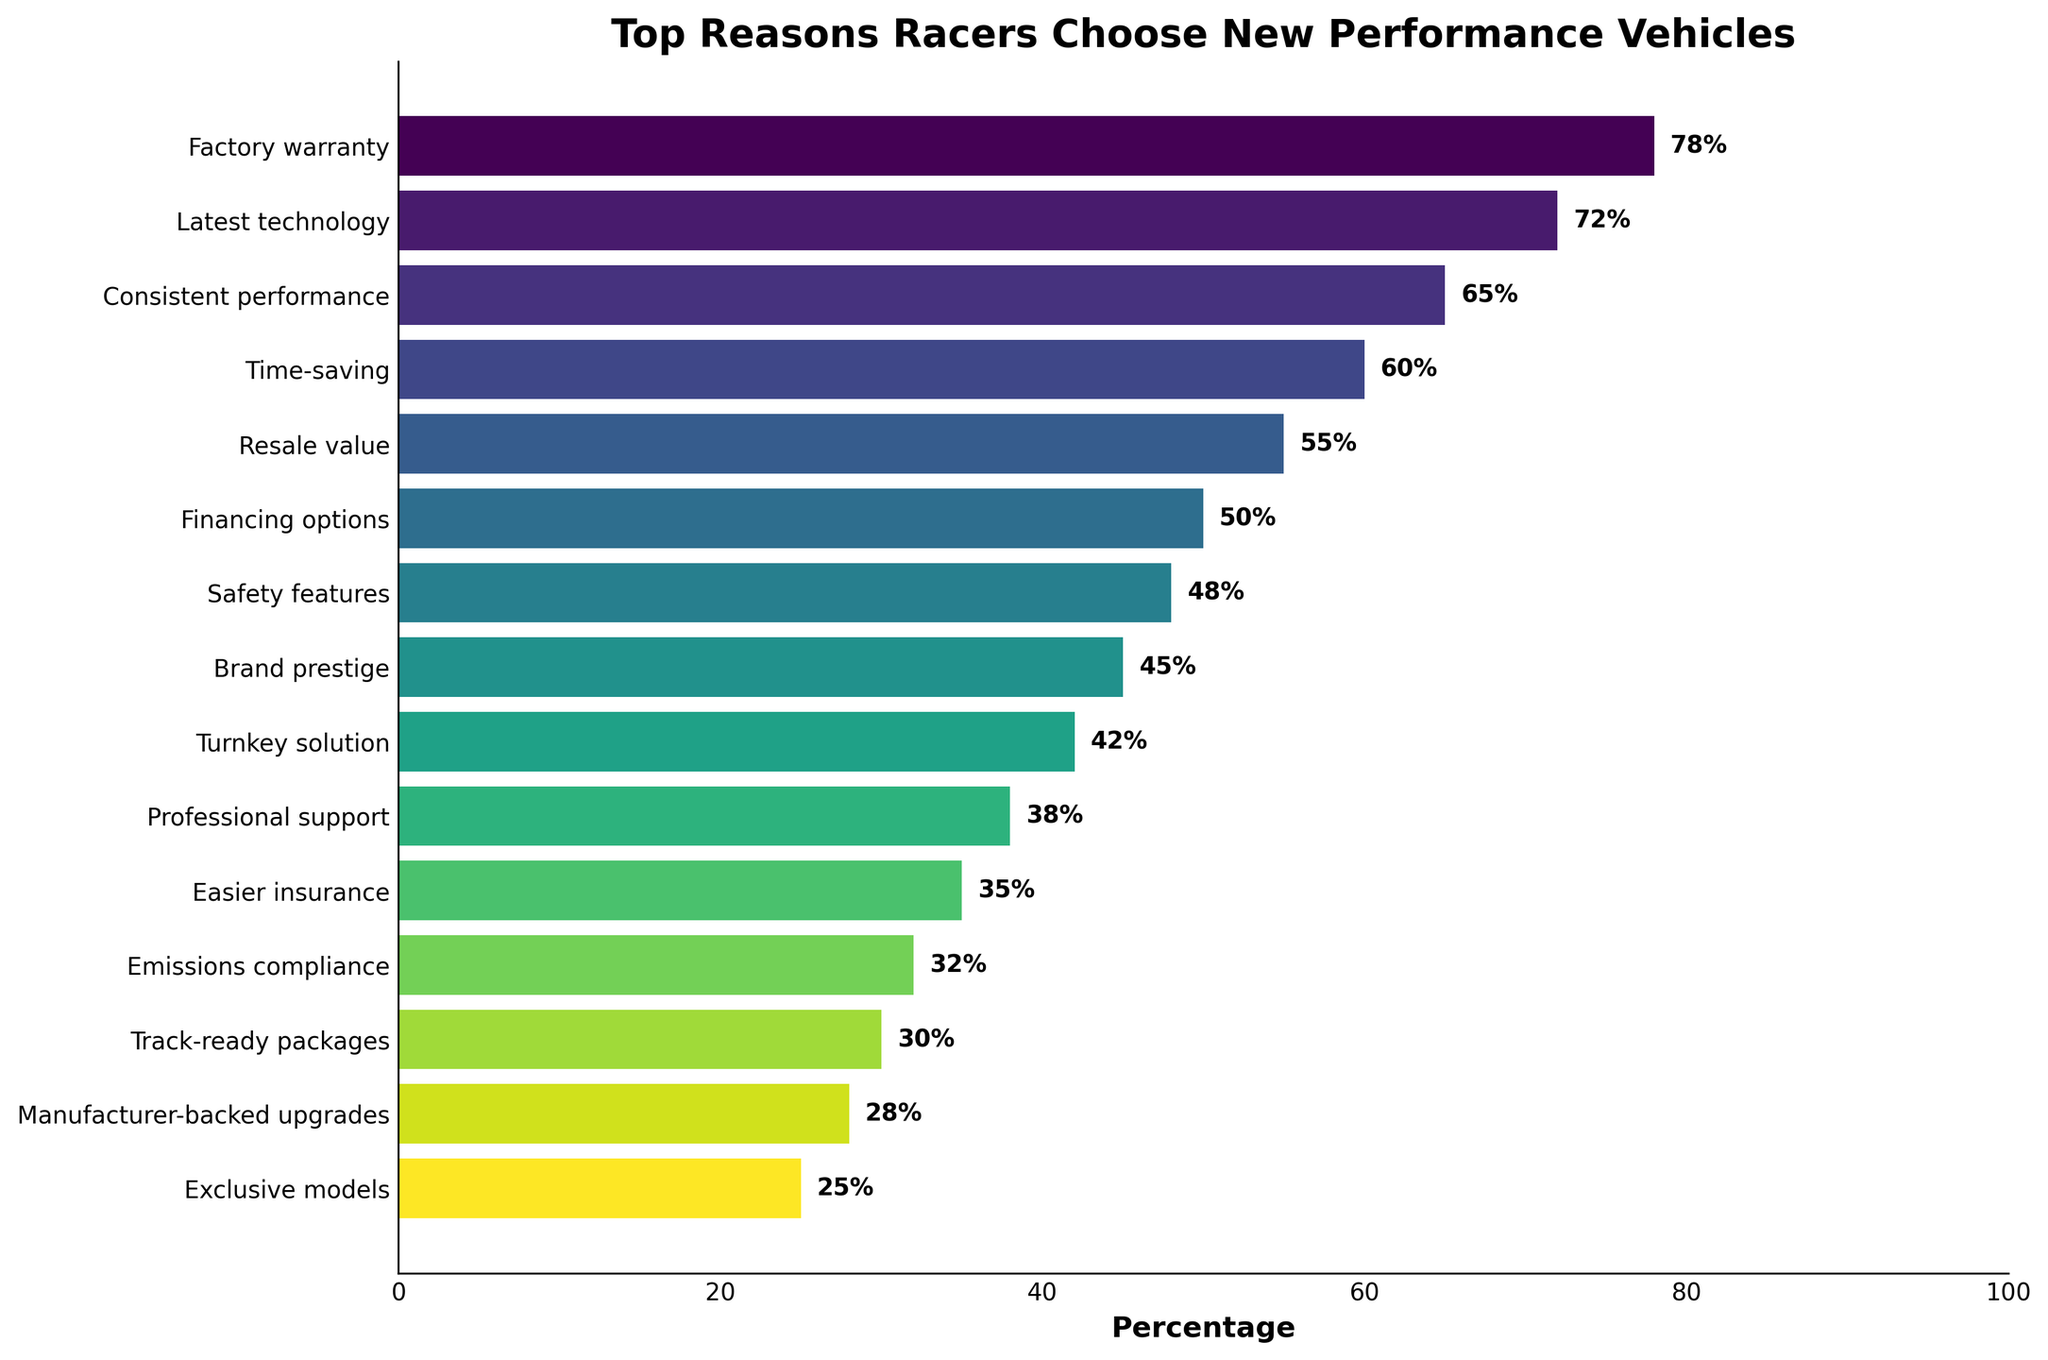what is the most common reason racers choose new performance vehicles? The chart shows different reasons ranked by percentage. The highest percentage indicates the most common reason. "Factory warranty" has the highest percentage at 78%.
Answer: Factory warranty What are the top three reasons racers choose new performance vehicles? The top three reasons are the ones with the highest percentages. From the chart, the top three reasons are "Factory warranty" (78%), "Latest technology" (72%), and "Consistent performance" (65%).
Answer: Factory warranty, Latest technology, Consistent performance What is the difference in percentage between 'Factory warranty' and 'Track-ready packages'? Locate the percentages for both reasons in the chart. 'Factory warranty' is 78% and 'Track-ready packages' is 30%. The difference is 78% - 30% = 48%.
Answer: 48% How many reasons have a percentage of 50% or higher? Count the bars that have percentages of 50% or higher. There are six reasons: "Factory warranty" (78%), "Latest technology" (72%), "Consistent performance" (65%), "Time-saving" (60%), "Resale value" (55%), and "Financing options" (50%).
Answer: 6 Is 'Easier insurance' a more common reason than 'Safety features'? Compare the percentages for 'Easier insurance' and 'Safety features'. 'Easier insurance' has a percentage of 35%, while 'Safety features' have a percentage of 48%. Since 35% is less than 48%, 'Easier insurance' is less common.
Answer: No What percentage of racers choose new performance vehicles due to 'Brand prestige'? The chart shows the percentage next to the reason 'Brand prestige'. It is 45%.
Answer: 45% Which reason is exactly in the middle in terms of percentage? To find the median, order the data from highest to lowest and find the middle value. There are 15 reasons, so the 8th reason is 'Turnkey solution' with 42%.
Answer: Turnkey solution How many reasons are specifically related to financial aspects (financing, resale value)? Identify reasons related to financial aspects and count them. The relevant reasons are 'Resale value' (55%) and 'Financing options' (50%).
Answer: 2 Which reason has the lowest percentage? The reason with the shortest bar (lowest percentage) is 'Exclusive models', which has 25%.
Answer: Exclusive models 